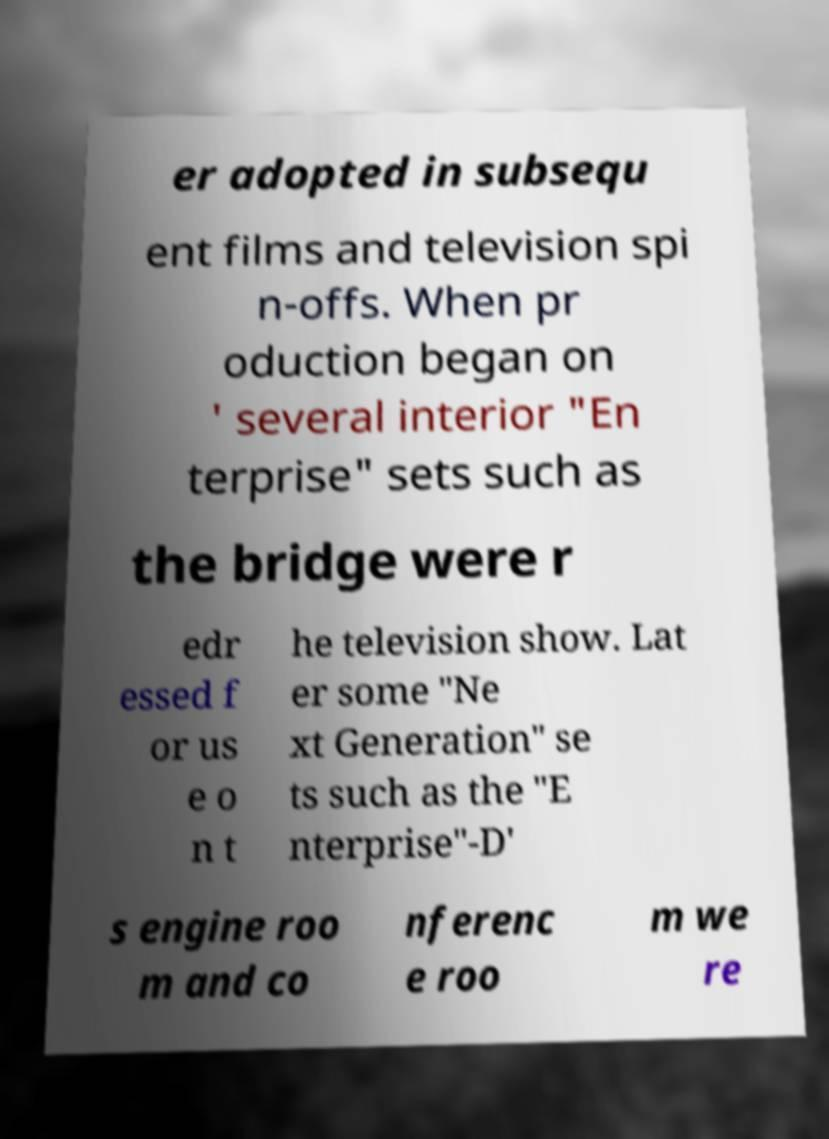Can you accurately transcribe the text from the provided image for me? er adopted in subsequ ent films and television spi n-offs. When pr oduction began on ' several interior "En terprise" sets such as the bridge were r edr essed f or us e o n t he television show. Lat er some "Ne xt Generation" se ts such as the "E nterprise"-D' s engine roo m and co nferenc e roo m we re 